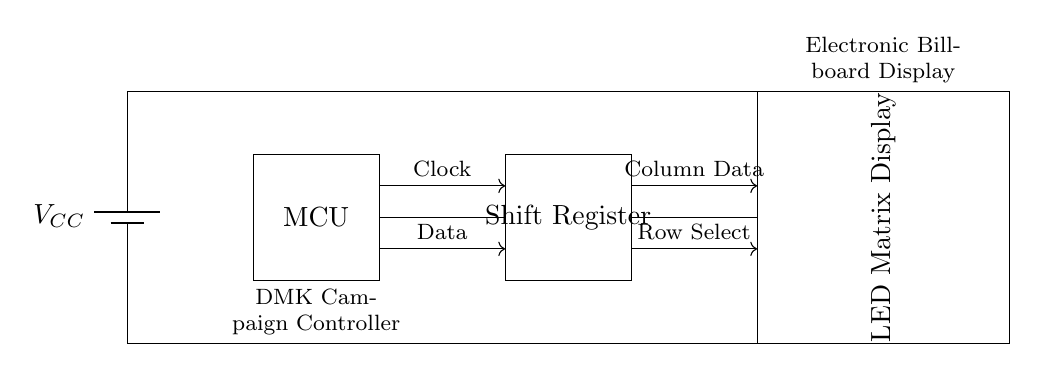What is the power supply voltage in this circuit? The voltage is represented by the label $V_{CC}$ on the battery component in the circuit diagram. The specific value of $V_{CC}$ is not provided, but it typically ranges from 5V to 12V in such applications.
Answer: VCC What component is used for data shift? The component labeled "Shift Register" is responsible for shifting data bits into the LED matrix. This type of component is commonly used in digital electronics to manage the serial communication of data.
Answer: Shift Register How many main components are shown in this circuit? The diagram illustrates three main components: the Microcontroller, the Shift Register, and the LED Matrix Display. Counting these components provides the total number.
Answer: Three What is the function of the microcontroller in this circuit? The microcontroller acts as the brain of the circuit, controlling data flow and operations between the Shift Register and the LED display. It processes input commands and sends coordinated signals to the other components as needed.
Answer: Control What is the role of the connections labeled "Row Select" and "Column Data"? These connections are used to select which row of the LED matrix is to be lit and to control the data sent to the corresponding columns. The "Row Select" activates a specific row, while "Column Data" sends the necessary information to illuminate the LEDs in that row.
Answer: Control of LED matrix Which component is responsible for illuminating the displayed information? The LED Matrix Display is the component that physically lights up to present the visual data, driven by the signals provided from the Shift Register and controlled by the Microcontroller.
Answer: LED Matrix Display 